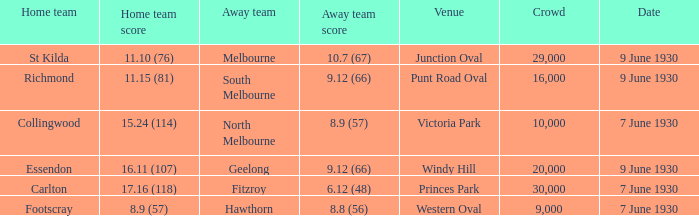What is the smallest crowd to see the away team score 10.7 (67)? 29000.0. 